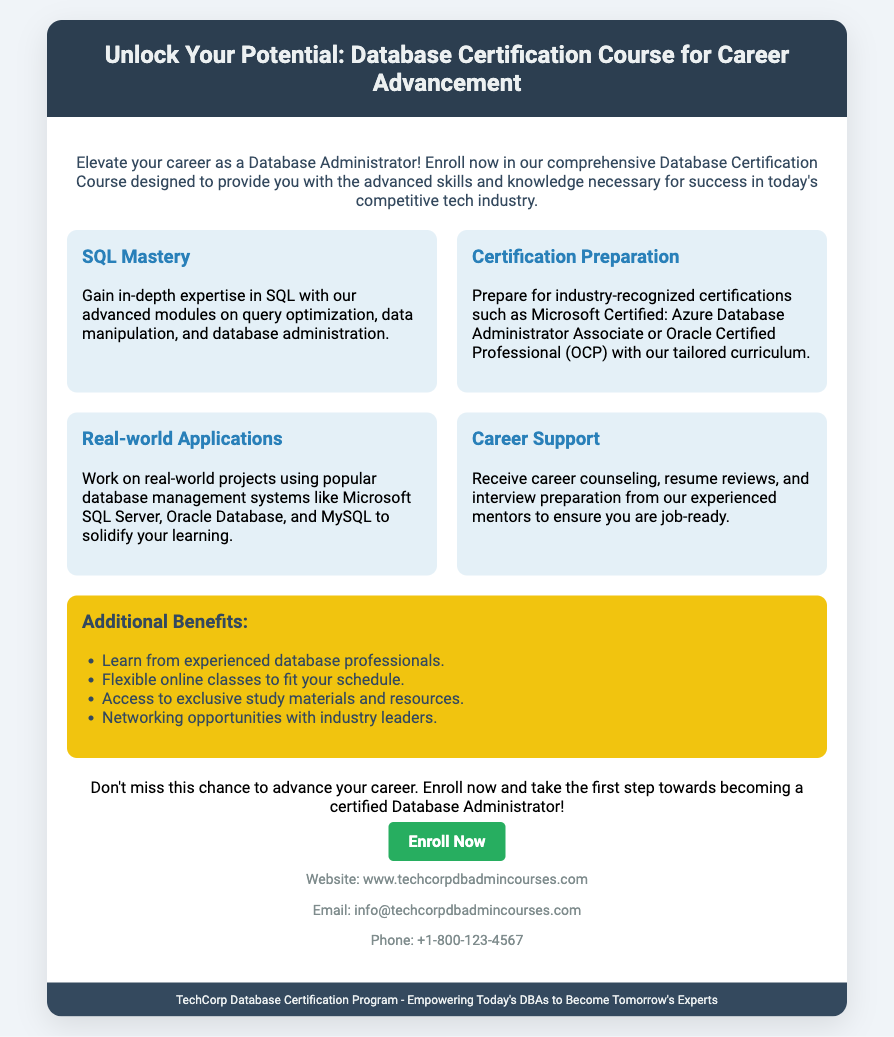What is the title of the course? The title of the course is prominently displayed in the header section of the document.
Answer: Database Certification Course for Career Advancement What is one of the skills covered in the course? The offer details section lists specific skills, including SQL mastery and certification preparation.
Answer: SQL Mastery What type of certification can you prepare for? The document mentions specific industry-recognized certifications that can be prepared for with the course.
Answer: Microsoft Certified: Azure Database Administrator Associate What support is provided to students? The document outlines various support systems offered to students, including career counseling and resume reviews.
Answer: Career Support How many offer items are listed in the document? The offer details section contains a specific number of items that illustrate course benefits.
Answer: Four What is one of the additional benefits mentioned? There is a section dedicated to additional benefits that provides various advantages for students in the program.
Answer: Flexible online classes What is the call to action phrase? The document includes a clear call to action that encourages readers to take specific action regarding the course.
Answer: Enroll Now What is the website for more information? The contact section provides a website where interested parties can seek more information about the course.
Answer: www.techcorpdbadmincourses.com What is the font style used in the document? The document includes a specific font style that enhances its readability and overall aesthetics.
Answer: Roboto 